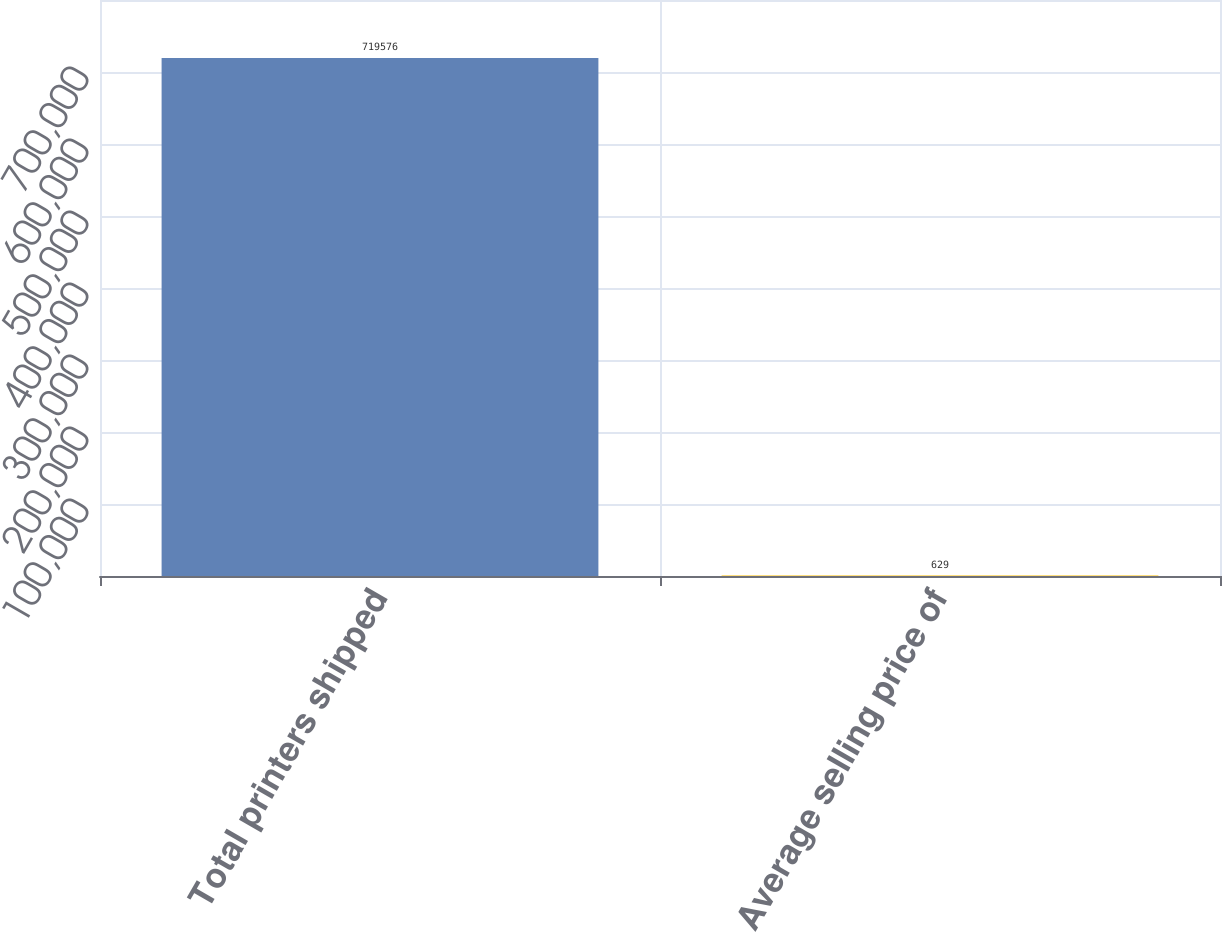Convert chart. <chart><loc_0><loc_0><loc_500><loc_500><bar_chart><fcel>Total printers shipped<fcel>Average selling price of<nl><fcel>719576<fcel>629<nl></chart> 